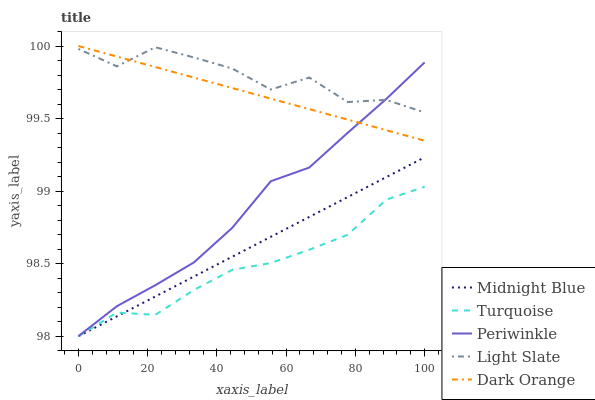Does Dark Orange have the minimum area under the curve?
Answer yes or no. No. Does Dark Orange have the maximum area under the curve?
Answer yes or no. No. Is Dark Orange the smoothest?
Answer yes or no. No. Is Dark Orange the roughest?
Answer yes or no. No. Does Dark Orange have the lowest value?
Answer yes or no. No. Does Turquoise have the highest value?
Answer yes or no. No. Is Midnight Blue less than Light Slate?
Answer yes or no. Yes. Is Dark Orange greater than Midnight Blue?
Answer yes or no. Yes. Does Midnight Blue intersect Light Slate?
Answer yes or no. No. 